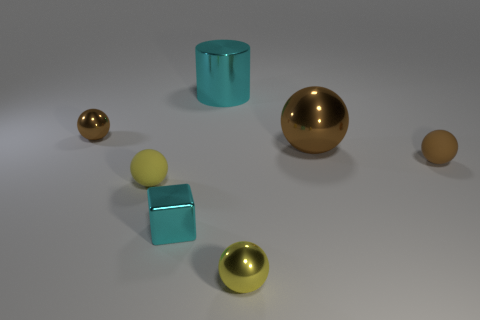What shape is the metallic object that is the same color as the large shiny cylinder?
Make the answer very short. Cube. Are there any big metal things that have the same color as the small cube?
Your answer should be compact. Yes. How many other objects are there of the same size as the yellow matte sphere?
Give a very brief answer. 4. The ball that is both to the left of the big cylinder and in front of the tiny brown matte sphere is made of what material?
Your response must be concise. Rubber. Is there anything else that is the same shape as the tiny cyan shiny object?
Your answer should be very brief. No. What is the color of the big cylinder that is made of the same material as the cube?
Make the answer very short. Cyan. How many objects are matte spheres or brown balls?
Offer a terse response. 4. Does the cyan shiny block have the same size as the brown thing to the left of the cyan metallic cube?
Make the answer very short. Yes. What is the color of the matte object to the right of the small yellow thing that is on the right side of the cyan cube that is in front of the big brown ball?
Your answer should be compact. Brown. What color is the tiny block?
Provide a succinct answer. Cyan. 